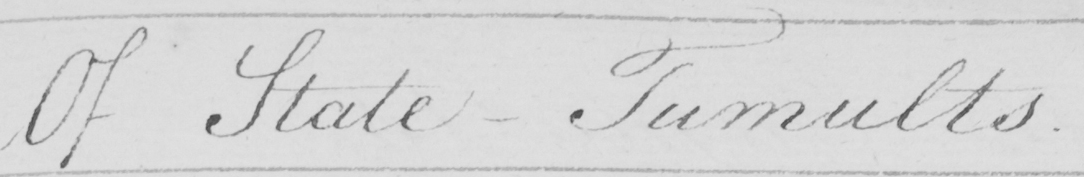Can you read and transcribe this handwriting? Of State-Tumults. 